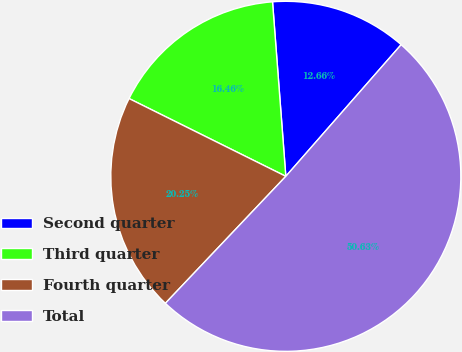<chart> <loc_0><loc_0><loc_500><loc_500><pie_chart><fcel>Second quarter<fcel>Third quarter<fcel>Fourth quarter<fcel>Total<nl><fcel>12.66%<fcel>16.46%<fcel>20.25%<fcel>50.63%<nl></chart> 